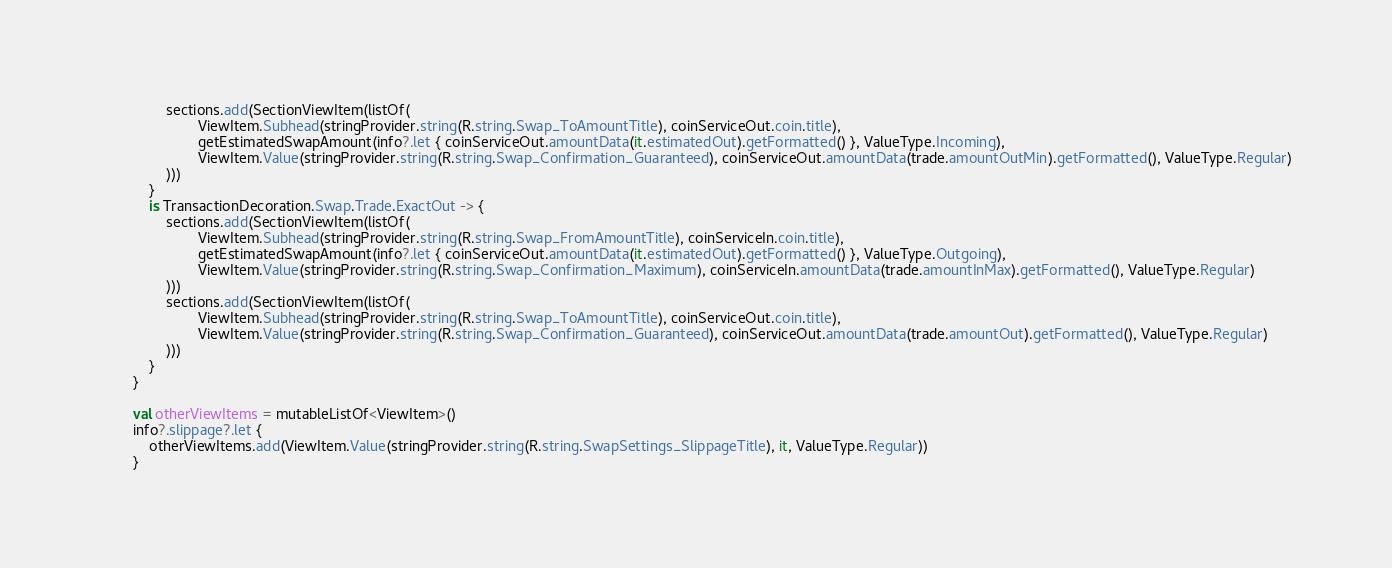<code> <loc_0><loc_0><loc_500><loc_500><_Kotlin_>                sections.add(SectionViewItem(listOf(
                        ViewItem.Subhead(stringProvider.string(R.string.Swap_ToAmountTitle), coinServiceOut.coin.title),
                        getEstimatedSwapAmount(info?.let { coinServiceOut.amountData(it.estimatedOut).getFormatted() }, ValueType.Incoming),
                        ViewItem.Value(stringProvider.string(R.string.Swap_Confirmation_Guaranteed), coinServiceOut.amountData(trade.amountOutMin).getFormatted(), ValueType.Regular)
                )))
            }
            is TransactionDecoration.Swap.Trade.ExactOut -> {
                sections.add(SectionViewItem(listOf(
                        ViewItem.Subhead(stringProvider.string(R.string.Swap_FromAmountTitle), coinServiceIn.coin.title),
                        getEstimatedSwapAmount(info?.let { coinServiceOut.amountData(it.estimatedOut).getFormatted() }, ValueType.Outgoing),
                        ViewItem.Value(stringProvider.string(R.string.Swap_Confirmation_Maximum), coinServiceIn.amountData(trade.amountInMax).getFormatted(), ValueType.Regular)
                )))
                sections.add(SectionViewItem(listOf(
                        ViewItem.Subhead(stringProvider.string(R.string.Swap_ToAmountTitle), coinServiceOut.coin.title),
                        ViewItem.Value(stringProvider.string(R.string.Swap_Confirmation_Guaranteed), coinServiceOut.amountData(trade.amountOut).getFormatted(), ValueType.Regular)
                )))
            }
        }

        val otherViewItems = mutableListOf<ViewItem>()
        info?.slippage?.let {
            otherViewItems.add(ViewItem.Value(stringProvider.string(R.string.SwapSettings_SlippageTitle), it, ValueType.Regular))
        }</code> 